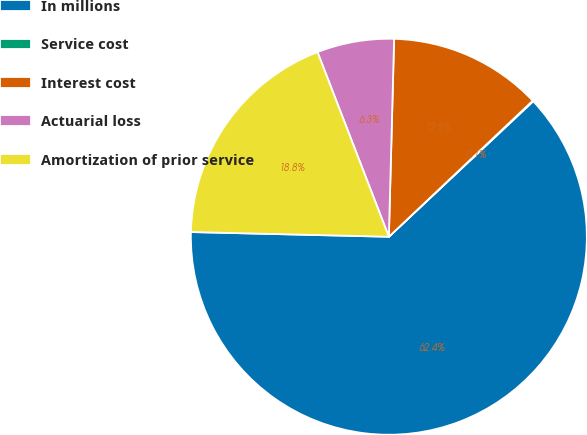Convert chart to OTSL. <chart><loc_0><loc_0><loc_500><loc_500><pie_chart><fcel>In millions<fcel>Service cost<fcel>Interest cost<fcel>Actuarial loss<fcel>Amortization of prior service<nl><fcel>62.37%<fcel>0.06%<fcel>12.52%<fcel>6.29%<fcel>18.75%<nl></chart> 